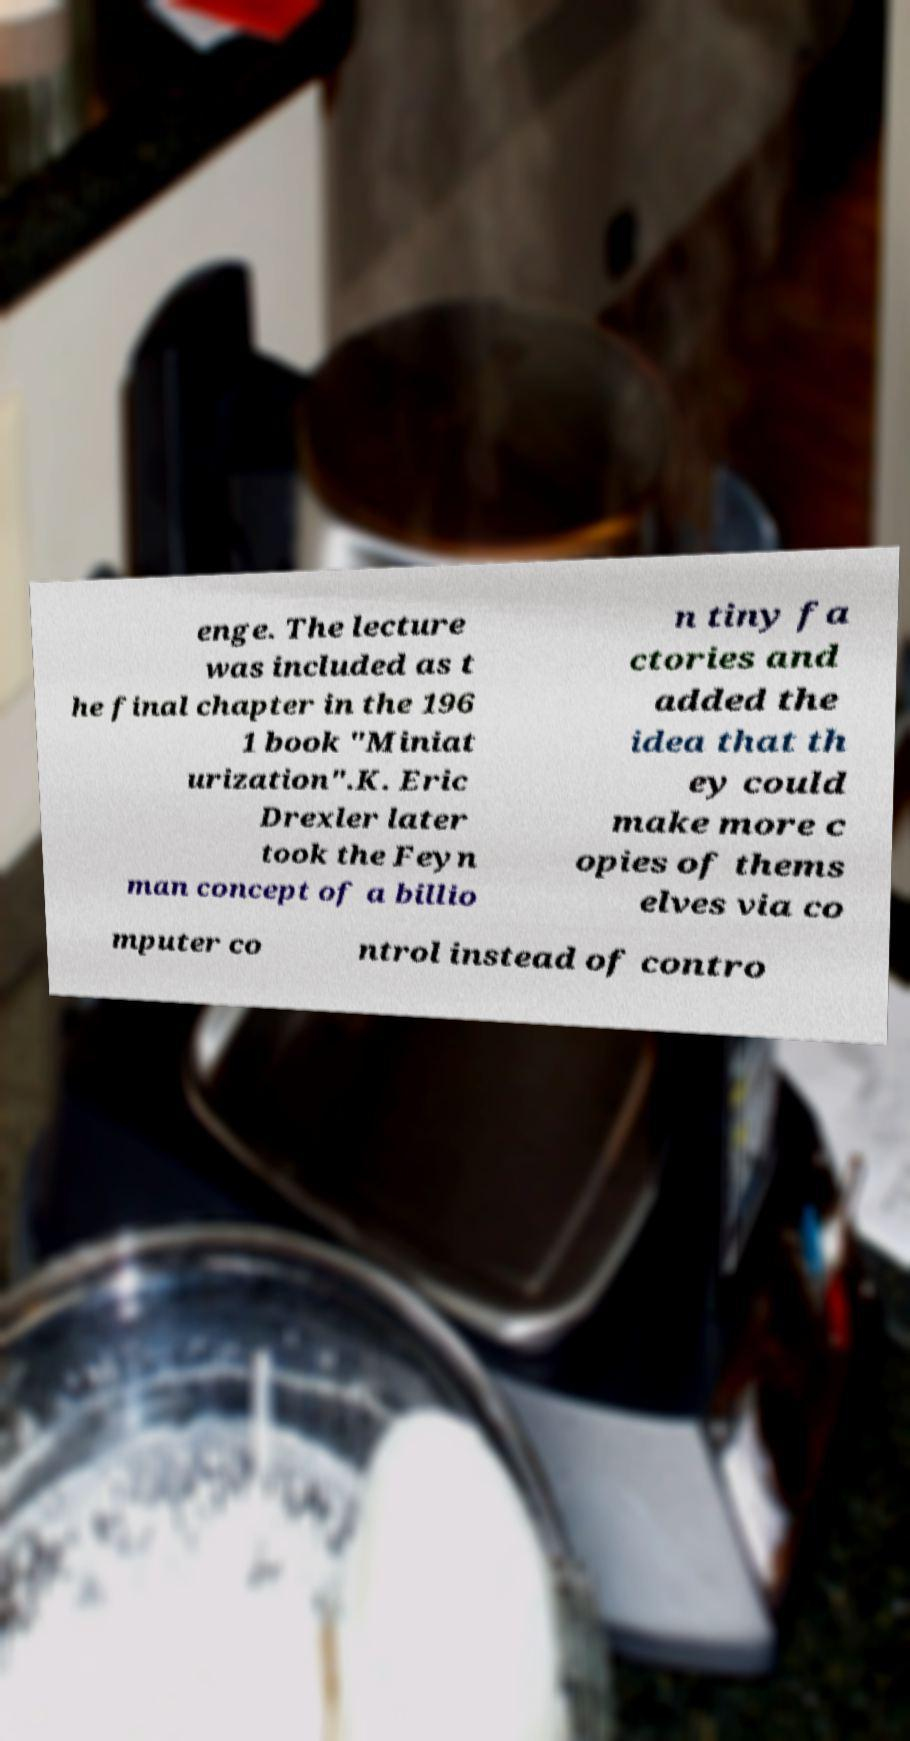Could you assist in decoding the text presented in this image and type it out clearly? enge. The lecture was included as t he final chapter in the 196 1 book "Miniat urization".K. Eric Drexler later took the Feyn man concept of a billio n tiny fa ctories and added the idea that th ey could make more c opies of thems elves via co mputer co ntrol instead of contro 